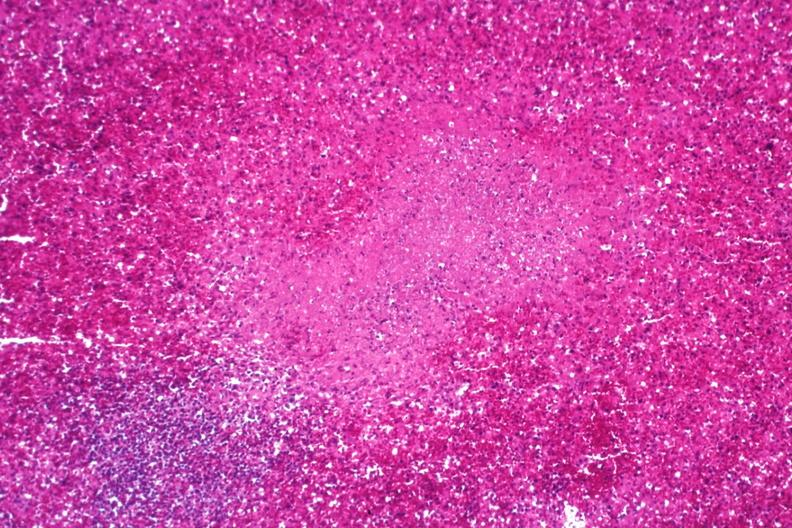s spleen present?
Answer the question using a single word or phrase. Yes 